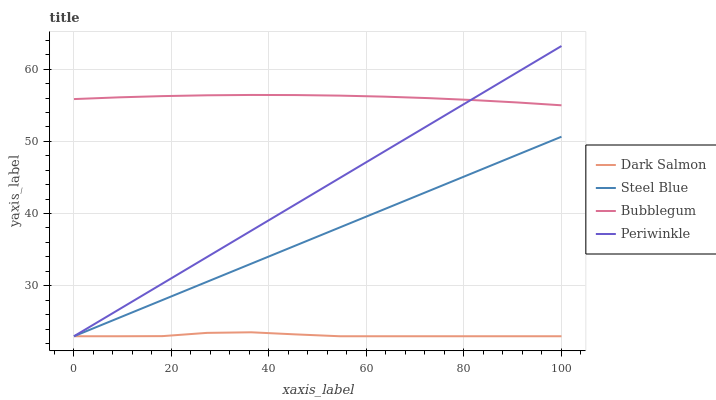Does Dark Salmon have the minimum area under the curve?
Answer yes or no. Yes. Does Bubblegum have the maximum area under the curve?
Answer yes or no. Yes. Does Bubblegum have the minimum area under the curve?
Answer yes or no. No. Does Dark Salmon have the maximum area under the curve?
Answer yes or no. No. Is Steel Blue the smoothest?
Answer yes or no. Yes. Is Dark Salmon the roughest?
Answer yes or no. Yes. Is Bubblegum the smoothest?
Answer yes or no. No. Is Bubblegum the roughest?
Answer yes or no. No. Does Periwinkle have the lowest value?
Answer yes or no. Yes. Does Bubblegum have the lowest value?
Answer yes or no. No. Does Periwinkle have the highest value?
Answer yes or no. Yes. Does Bubblegum have the highest value?
Answer yes or no. No. Is Dark Salmon less than Bubblegum?
Answer yes or no. Yes. Is Bubblegum greater than Dark Salmon?
Answer yes or no. Yes. Does Bubblegum intersect Periwinkle?
Answer yes or no. Yes. Is Bubblegum less than Periwinkle?
Answer yes or no. No. Is Bubblegum greater than Periwinkle?
Answer yes or no. No. Does Dark Salmon intersect Bubblegum?
Answer yes or no. No. 